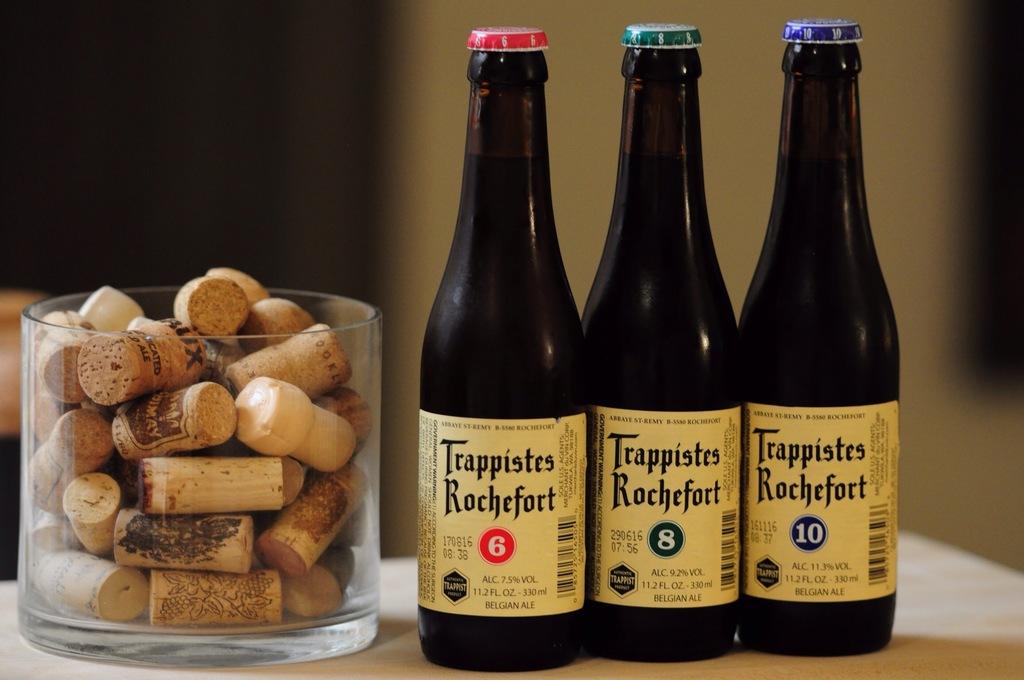What is the brand of the drink?
Your answer should be compact. Trappistes rochefort. How many ounces are in each bottle?
Provide a short and direct response. 11.2. 